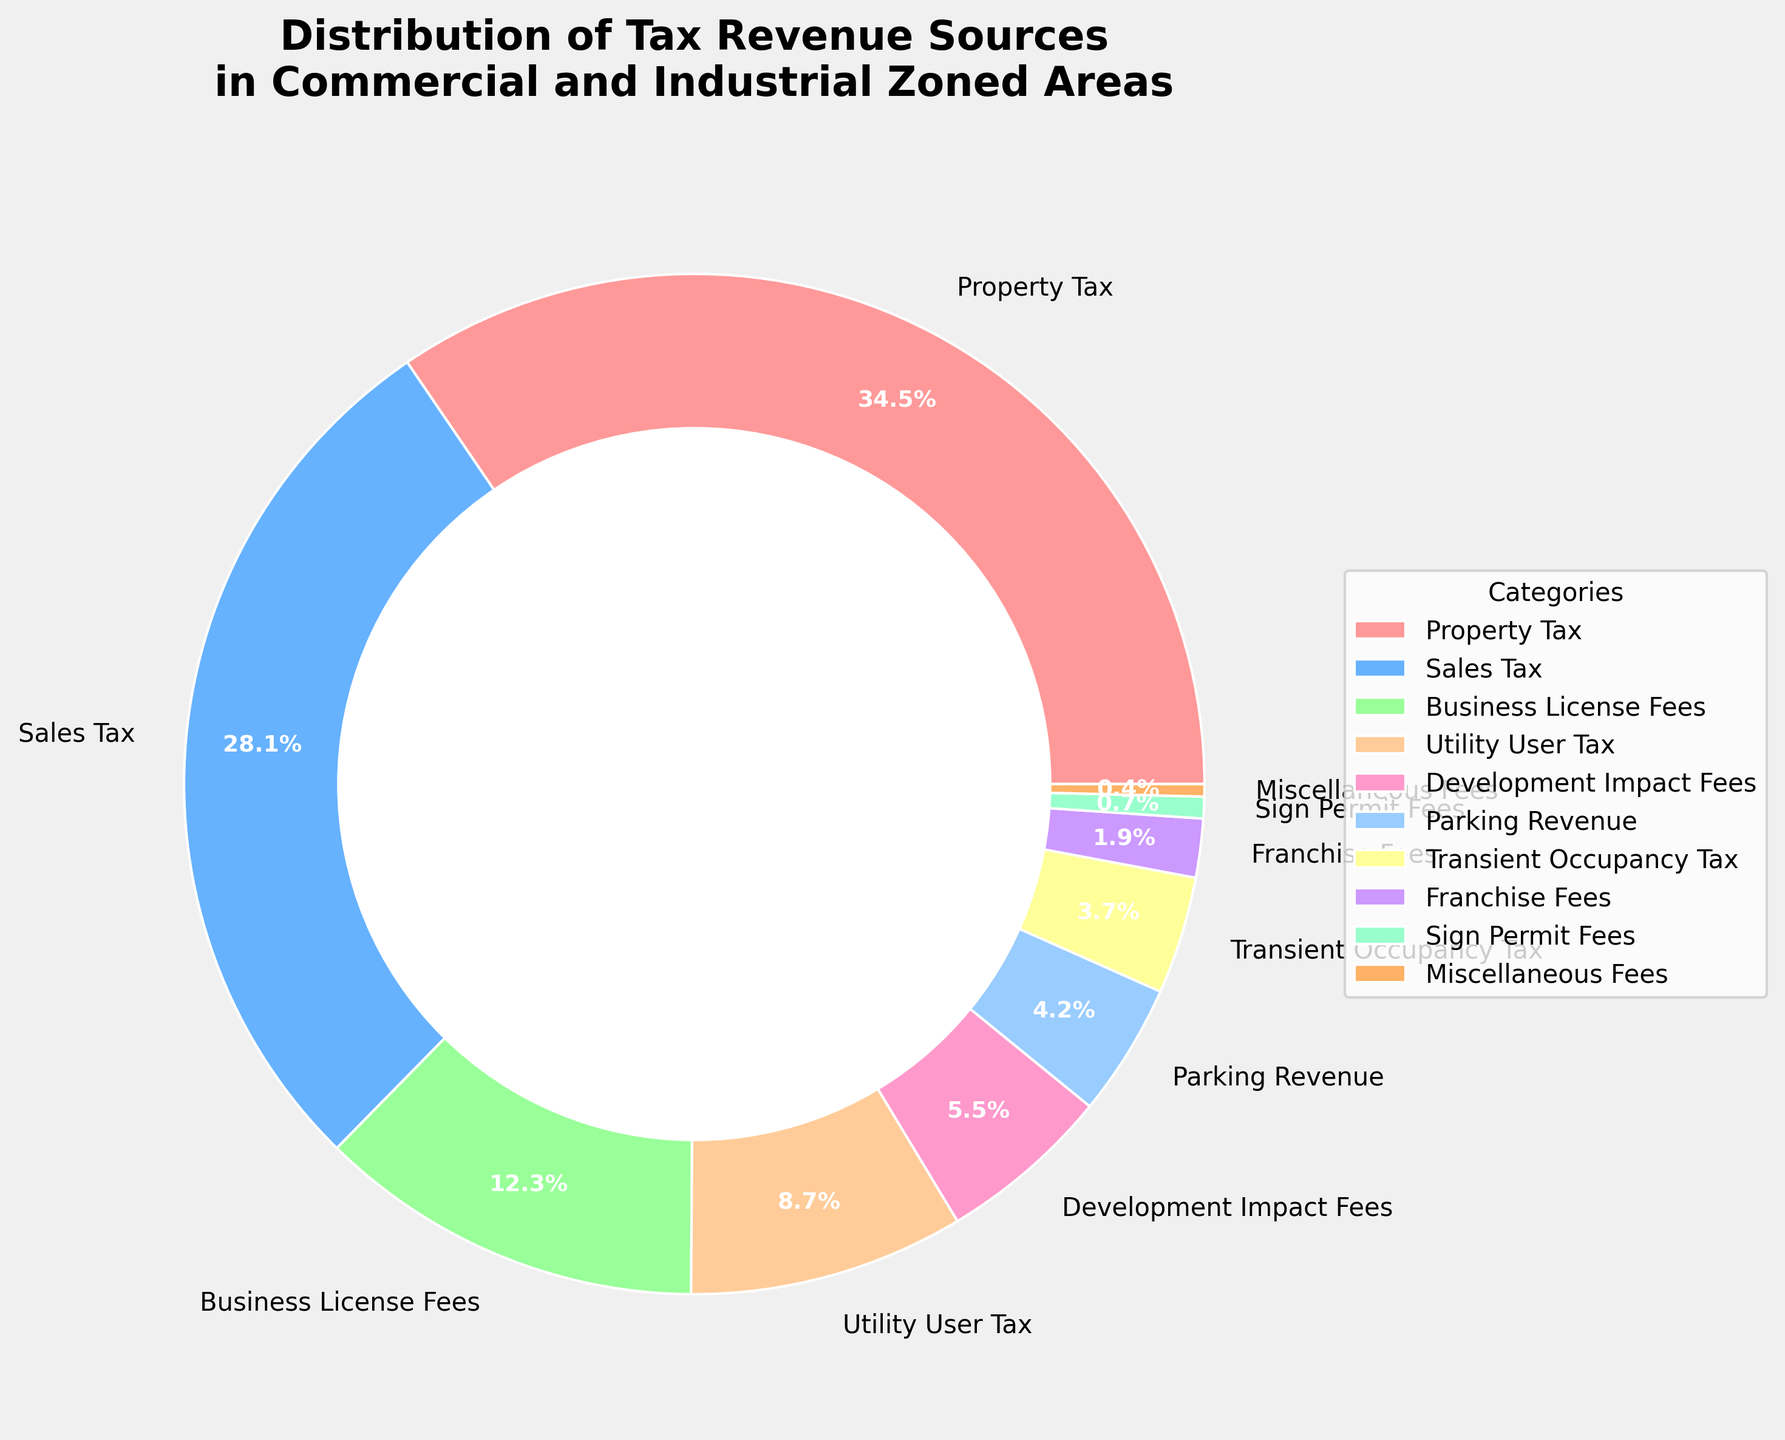What is the largest source of tax revenue? The largest segment in the pie chart represents the highest percentage. By comparing all segments, we can see that the "Property Tax" category has the largest segment, labeled 35.2%.
Answer: Property Tax Which source contributes the least to the tax revenue? The smallest segment in the pie chart represents the lowest percentage. By comparing all segments, we see that the "Miscellaneous Fees" category has the smallest segment, labeled 0.4%.
Answer: Miscellaneous Fees How much more does the Property Tax revenue contribute compared to Sales Tax revenue? The Property Tax contribution is 35.2%, and the Sales Tax contribution is 28.7%. Subtract 28.7 from 35.2 to find the difference, 35.2 - 28.7 = 6.5%.
Answer: 6.5% What is the combined percentage of Business License Fees and Utility User Tax? The Business License Fees contribution is 12.5%, and the Utility User Tax contribution is 8.9%. Adding these together, 12.5 + 8.9 = 21.4%.
Answer: 21.4% Which two categories together make up approximately one-third of the total tax revenue sources? One-third of 100% is approximately 33.3%. Looking at the chart, "Property Tax" is 35.2% and any segment close to one-third needs another smaller segment. The next substantial segment is "Sales Tax" at 28.7%. Adding these two, 35.2 + 28.7 = 63.9%. However, for approximately one-third, "Business License Fees" 12.5% and "Utility User Tax" 8.9% together make 21.4%, together with "Sales Tax" at 28.7% equals 50.1%, still too high. For exact one-third closer consideration needed.
Answer: Property Tax (35.2%) Compare the contribution of Utility User Tax to the combined contributions of Development Impact Fees and Parking Revenue. Is it higher or lower? Utility User Tax contributes 8.9%. Development Impact Fees and Parking Revenue contribute 5.6% and 4.3% respectively. Adding these together, 5.6 + 4.3 = 9.9%. The combined contribution of Development Impact Fees and Parking Revenue (9.9%) is higher than Utility User Tax (8.9%).
Answer: Lower How many sources contribute less than 10% each? Observing the pie chart, the segments contributing less than 10% are: Business License Fees (12.5% > 10%), Utility User Tax (8.9% < 10%), Development Impact Fees (5.6%), Parking Revenue (4.3%), Transient Occupancy Tax (3.8%), Franchise Fees (1.9%), Sign Permit Fees (0.7%), Miscellaneous Fees (0.4%). In total there are 7 sources that contribute less than 10%.
Answer: 7 Calculate the average percentage contribution of all tax revenue sources. Sum up all percentage contributions: 35.2 + 28.7 + 12.5 + 8.9 + 5.6 + 4.3 + 3.8 + 1.9 + 0.7 + 0.4 = 102%. The average contribution per source is 102% (sum) / 10 (number of sources) = 10.2%.
Answer: 10.2% What is the difference between the combined percentage of the highest and lowest four categories? Highest four percentages: Property Tax (35.2%), Sales Tax (28.7%), Business License Fees (12.5%), Utility User Tax (8.9%) = 85.3%. Lowest four percentages: Sign Permit Fees (0.7%), Miscellaneous Fees (0.4%), Franchise Fees (1.9%), Transient Occupancy Tax (3.8%) = 6.8%. Difference: 85.3 - 6.8 = 78.5%.
Answer: 78.5% 